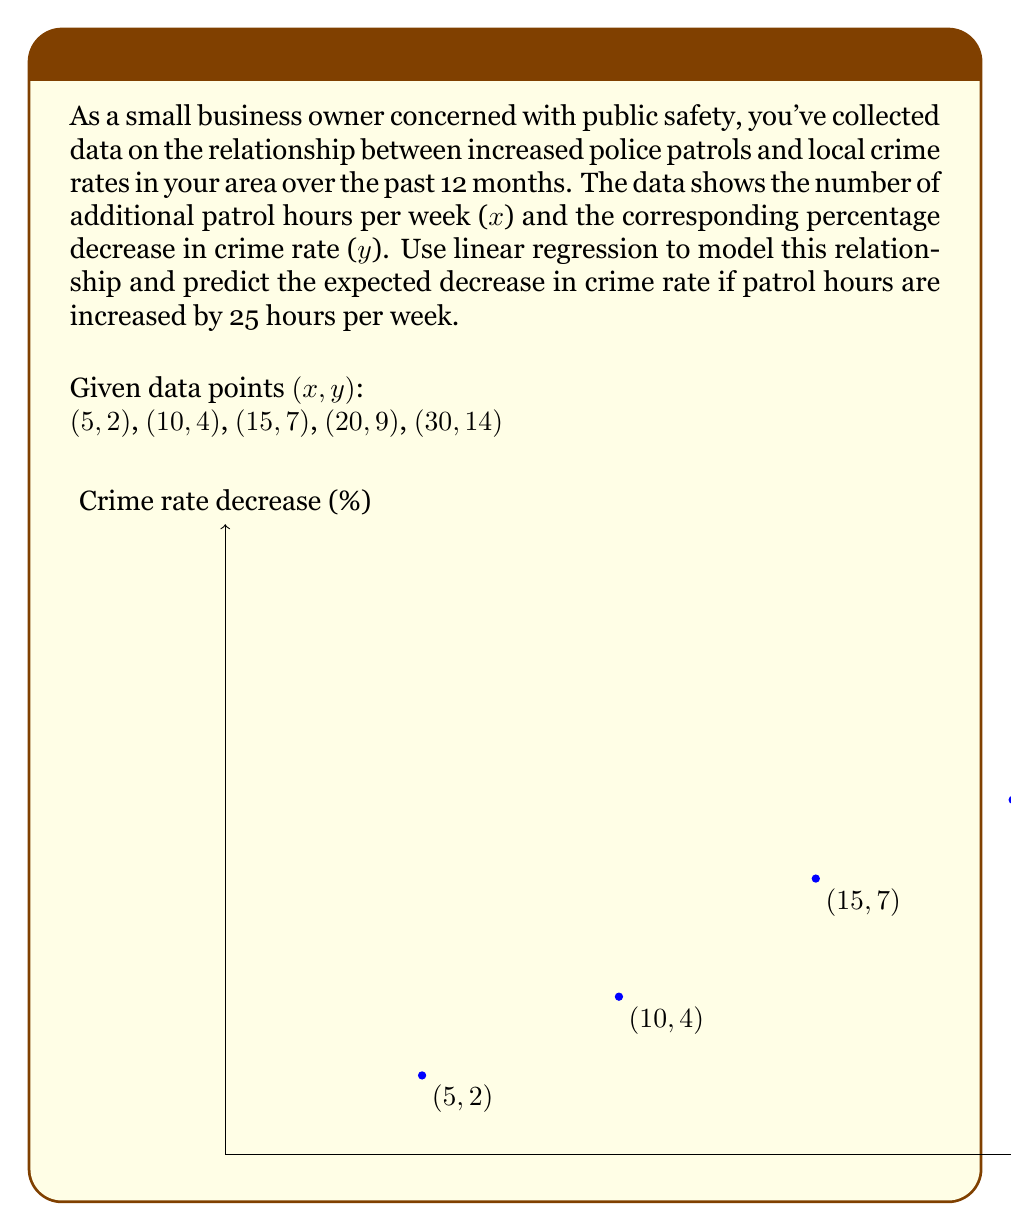Provide a solution to this math problem. To solve this problem, we'll use linear regression to find the best-fit line and then use it to make a prediction.

Step 1: Calculate the means of x and y
$$\bar{x} = \frac{5+10+15+20+30}{5} = 16$$
$$\bar{y} = \frac{2+4+7+9+14}{5} = 7.2$$

Step 2: Calculate the slope (m) using the formula:
$$m = \frac{\sum(x_i - \bar{x})(y_i - \bar{y})}{\sum(x_i - \bar{x})^2}$$

Calculate the numerator and denominator:
$$(5-16)(2-7.2) + (10-16)(4-7.2) + (15-16)(7-7.2) + (20-16)(9-7.2) + (30-16)(14-7.2) = 418$$
$$(5-16)^2 + (10-16)^2 + (15-16)^2 + (20-16)^2 + (30-16)^2 = 450$$

$$m = \frac{418}{450} = 0.4622$$

Step 3: Calculate the y-intercept (b) using the formula:
$$b = \bar{y} - m\bar{x}$$
$$b = 7.2 - 0.4622 \times 16 = -0.1956$$

Step 4: Write the equation of the regression line
$$y = 0.4622x - 0.1956$$

Step 5: Predict the decrease in crime rate for 25 additional patrol hours
$$y = 0.4622 \times 25 - 0.1956 = 11.3594$$

Therefore, the expected decrease in crime rate for 25 additional patrol hours per week is approximately 11.36%.
Answer: 11.36% 